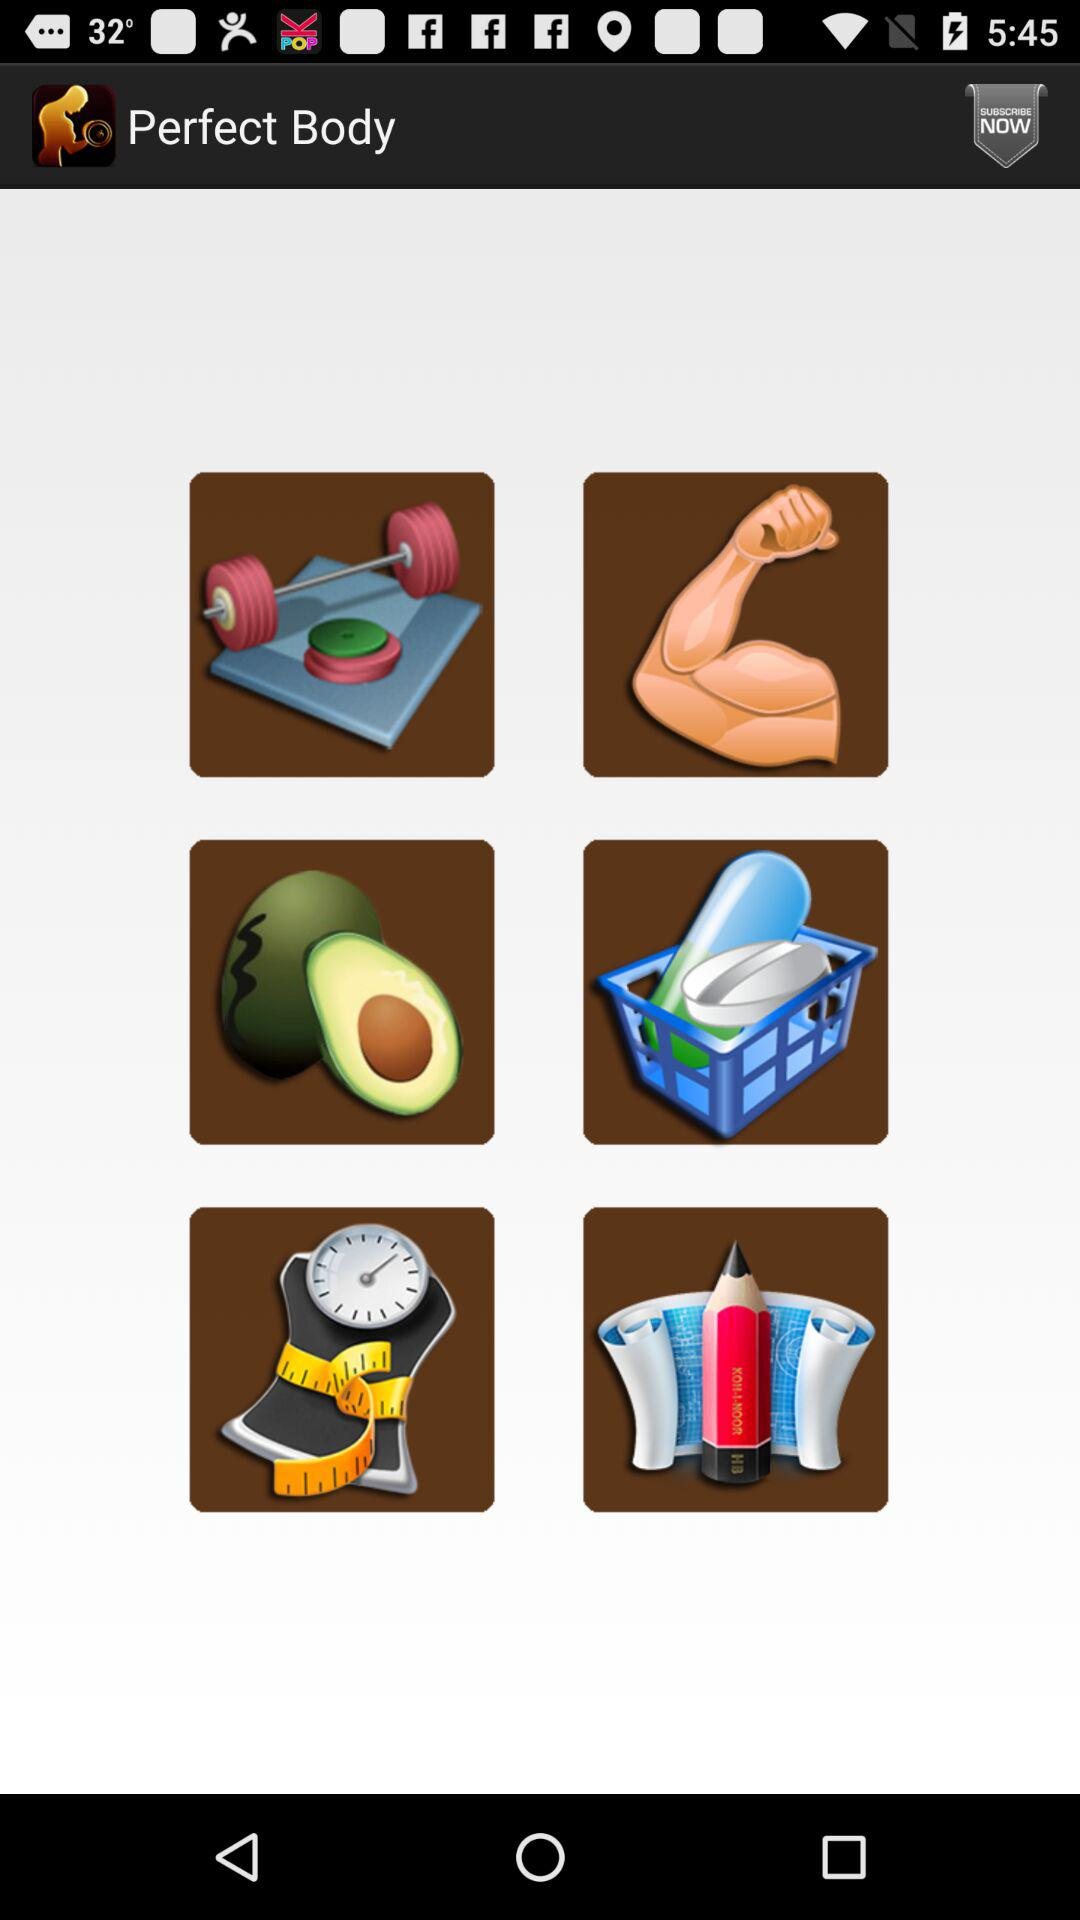What is the application name? The application name is "Perfect Body". 